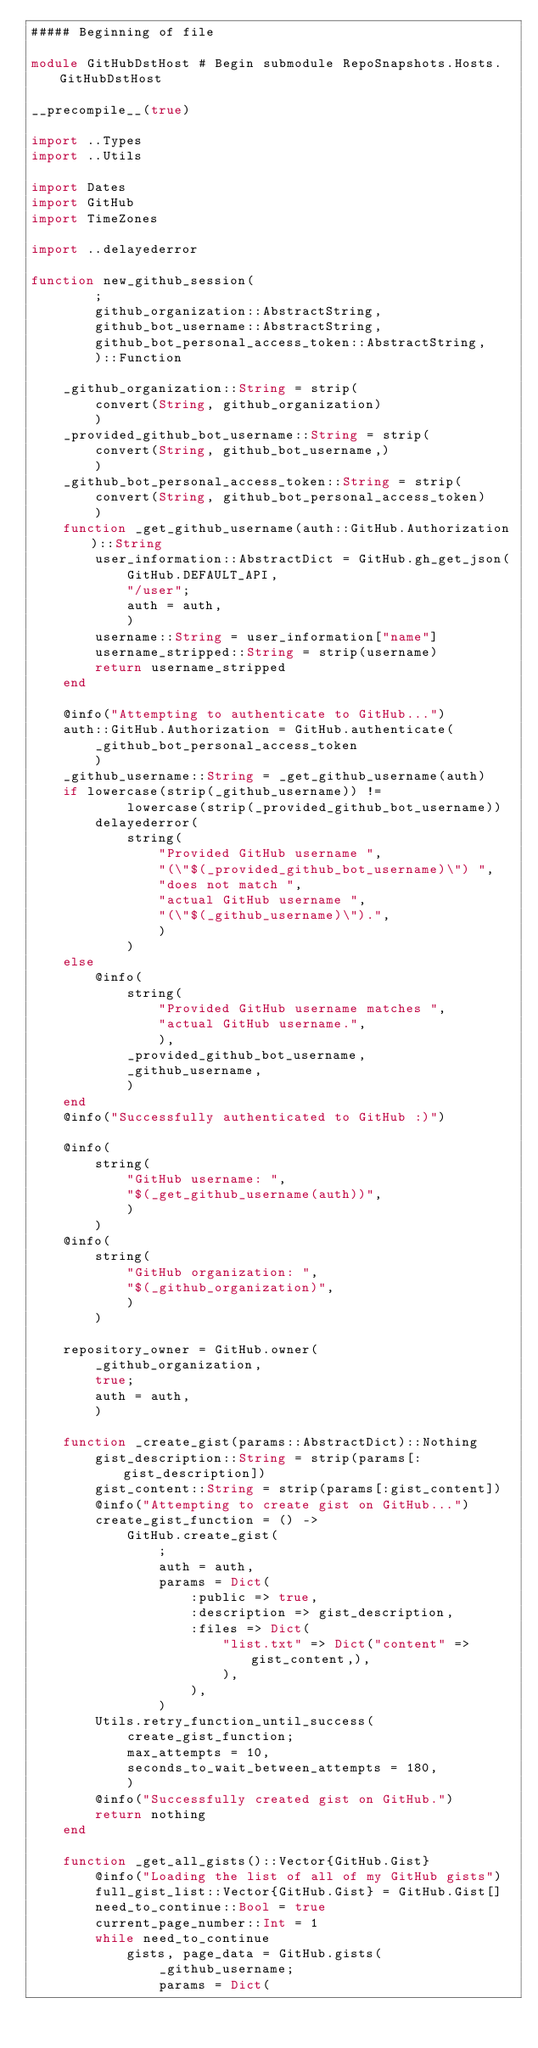<code> <loc_0><loc_0><loc_500><loc_500><_Julia_>##### Beginning of file

module GitHubDstHost # Begin submodule RepoSnapshots.Hosts.GitHubDstHost

__precompile__(true)

import ..Types
import ..Utils

import Dates
import GitHub
import TimeZones

import ..delayederror

function new_github_session(
        ;
        github_organization::AbstractString,
        github_bot_username::AbstractString,
        github_bot_personal_access_token::AbstractString,
        )::Function

    _github_organization::String = strip(
        convert(String, github_organization)
        )
    _provided_github_bot_username::String = strip(
        convert(String, github_bot_username,)
        )
    _github_bot_personal_access_token::String = strip(
        convert(String, github_bot_personal_access_token)
        )
    function _get_github_username(auth::GitHub.Authorization)::String
        user_information::AbstractDict = GitHub.gh_get_json(
            GitHub.DEFAULT_API,
            "/user";
            auth = auth,
            )
        username::String = user_information["name"]
        username_stripped::String = strip(username)
        return username_stripped
    end

    @info("Attempting to authenticate to GitHub...")
    auth::GitHub.Authorization = GitHub.authenticate(
        _github_bot_personal_access_token
        )
    _github_username::String = _get_github_username(auth)
    if lowercase(strip(_github_username)) !=
            lowercase(strip(_provided_github_bot_username))
        delayederror(
            string(
                "Provided GitHub username ",
                "(\"$(_provided_github_bot_username)\") ",
                "does not match ",
                "actual GitHub username ",
                "(\"$(_github_username)\").",
                )
            )
    else
        @info(
            string(
                "Provided GitHub username matches ",
                "actual GitHub username.",
                ),
            _provided_github_bot_username,
            _github_username,
            )
    end
    @info("Successfully authenticated to GitHub :)")

    @info(
        string(
            "GitHub username: ",
            "$(_get_github_username(auth))",
            )
        )
    @info(
        string(
            "GitHub organization: ",
            "$(_github_organization)",
            )
        )

    repository_owner = GitHub.owner(
        _github_organization,
        true;
        auth = auth,
        )

    function _create_gist(params::AbstractDict)::Nothing
        gist_description::String = strip(params[:gist_description])
        gist_content::String = strip(params[:gist_content])
        @info("Attempting to create gist on GitHub...")
        create_gist_function = () ->
            GitHub.create_gist(
                ;
                auth = auth,
                params = Dict(
                    :public => true,
                    :description => gist_description,
                    :files => Dict(
                        "list.txt" => Dict("content" => gist_content,),
                        ),
                    ),
                )
        Utils.retry_function_until_success(
            create_gist_function;
            max_attempts = 10,
            seconds_to_wait_between_attempts = 180,
            )
        @info("Successfully created gist on GitHub.")
        return nothing
    end

    function _get_all_gists()::Vector{GitHub.Gist}
        @info("Loading the list of all of my GitHub gists")
        full_gist_list::Vector{GitHub.Gist} = GitHub.Gist[]
        need_to_continue::Bool = true
        current_page_number::Int = 1
        while need_to_continue
            gists, page_data = GitHub.gists(
                _github_username;
                params = Dict(</code> 